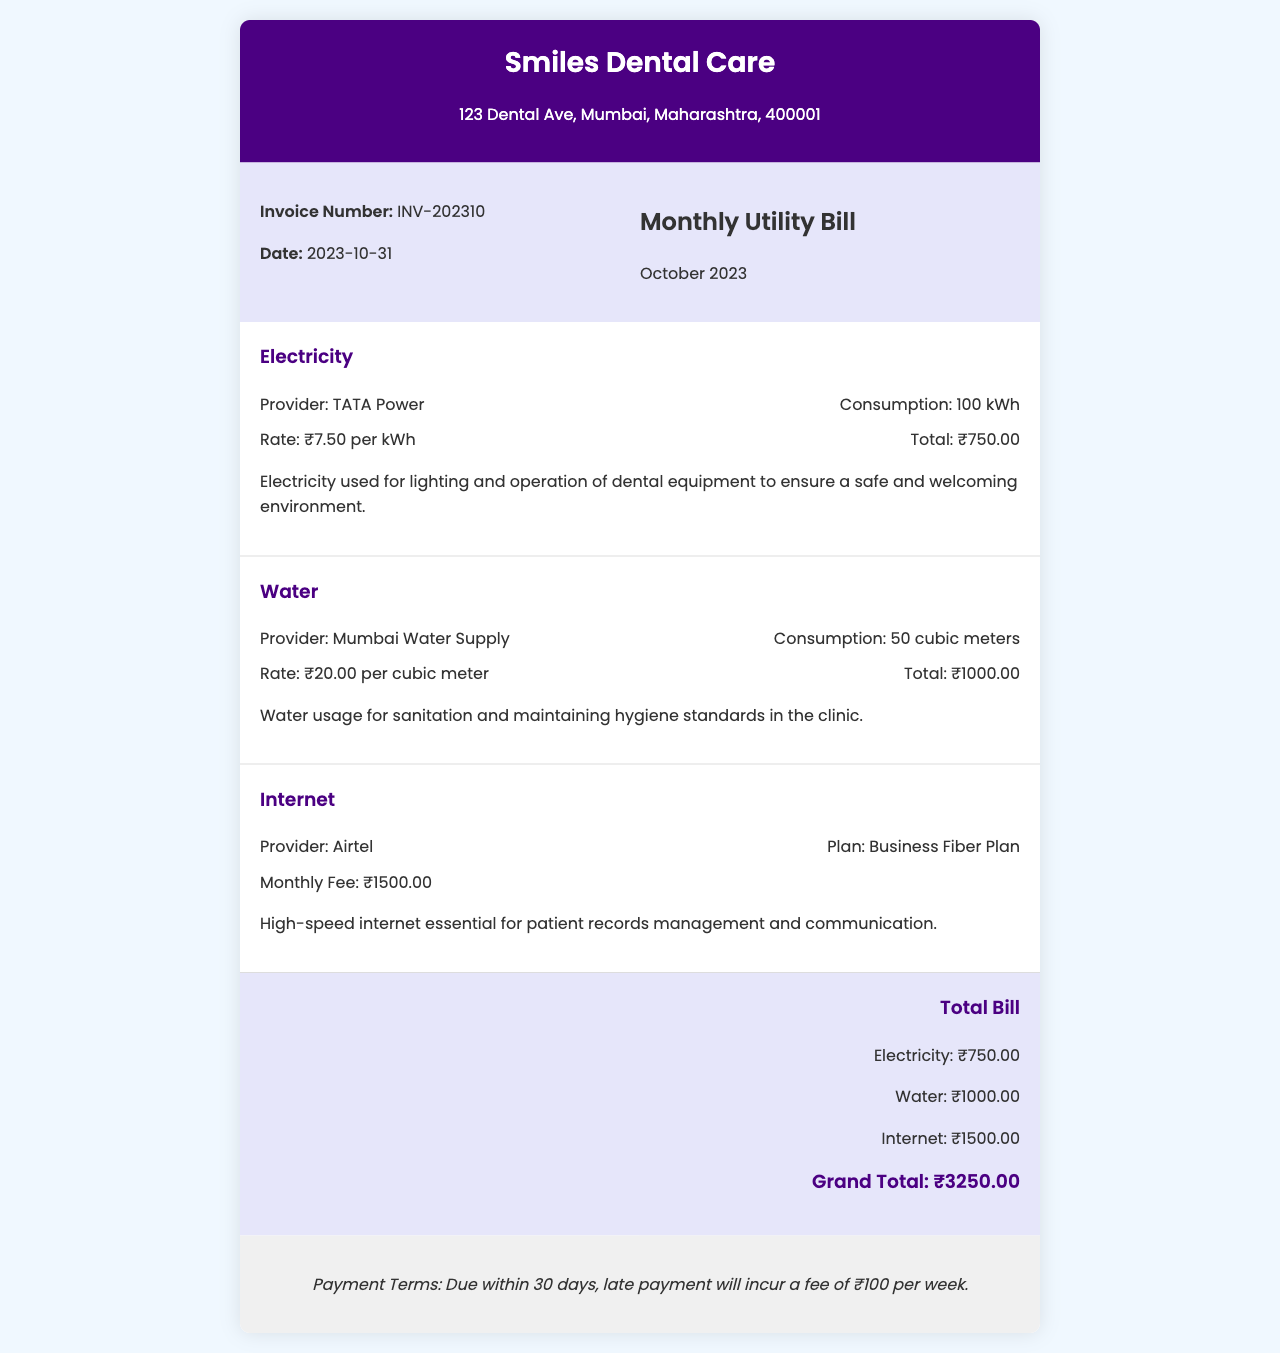What is the invoice number? The invoice number is specified in the document under the invoice details section.
Answer: INV-202310 What is the total bill amount? The total bill amount is calculated at the end of the invoice, summing up the individual utility costs.
Answer: ₹3250.00 Who is the electricity provider? The electricity provider's name is mentioned in the utility section for electricity.
Answer: TATA Power What is the water consumption for October 2023? The document specifies the water consumption under the details of the water utility section.
Answer: 50 cubic meters What service does the internet expense cover? The description of the internet expense indicates its purpose related to the clinic's operations.
Answer: Patient records management and communication How much is the monthly fee for internet service? This amount is explicitly provided in the utility section for internet services.
Answer: ₹1500.00 When is the payment due by? The invoice states the payment terms in the last section which specifies the due period.
Answer: Within 30 days What is the rate for electricity per kWh? The rate can be found in the electricity utility details section of the document.
Answer: ₹7.50 per kWh What is the description of water usage in the clinic? The document provides a brief explanation regarding the purpose of water usage under the water utility section.
Answer: Maintaining hygiene standards in the clinic 